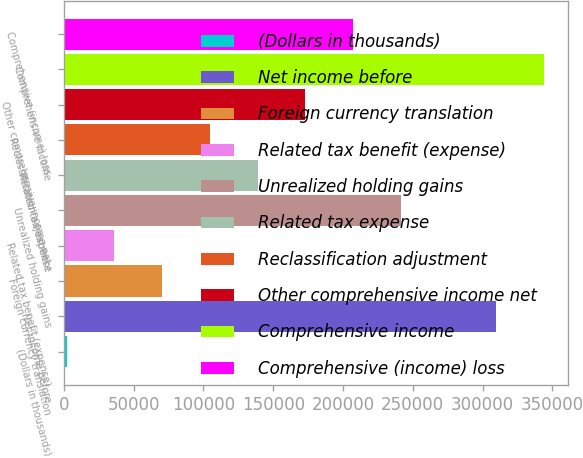Convert chart. <chart><loc_0><loc_0><loc_500><loc_500><bar_chart><fcel>(Dollars in thousands)<fcel>Net income before<fcel>Foreign currency translation<fcel>Related tax benefit (expense)<fcel>Unrealized holding gains<fcel>Related tax expense<fcel>Reclassification adjustment<fcel>Other comprehensive income net<fcel>Comprehensive income<fcel>Comprehensive (income) loss<nl><fcel>2011<fcel>309845<fcel>70418.6<fcel>36214.8<fcel>241438<fcel>138826<fcel>104622<fcel>173030<fcel>344049<fcel>207234<nl></chart> 